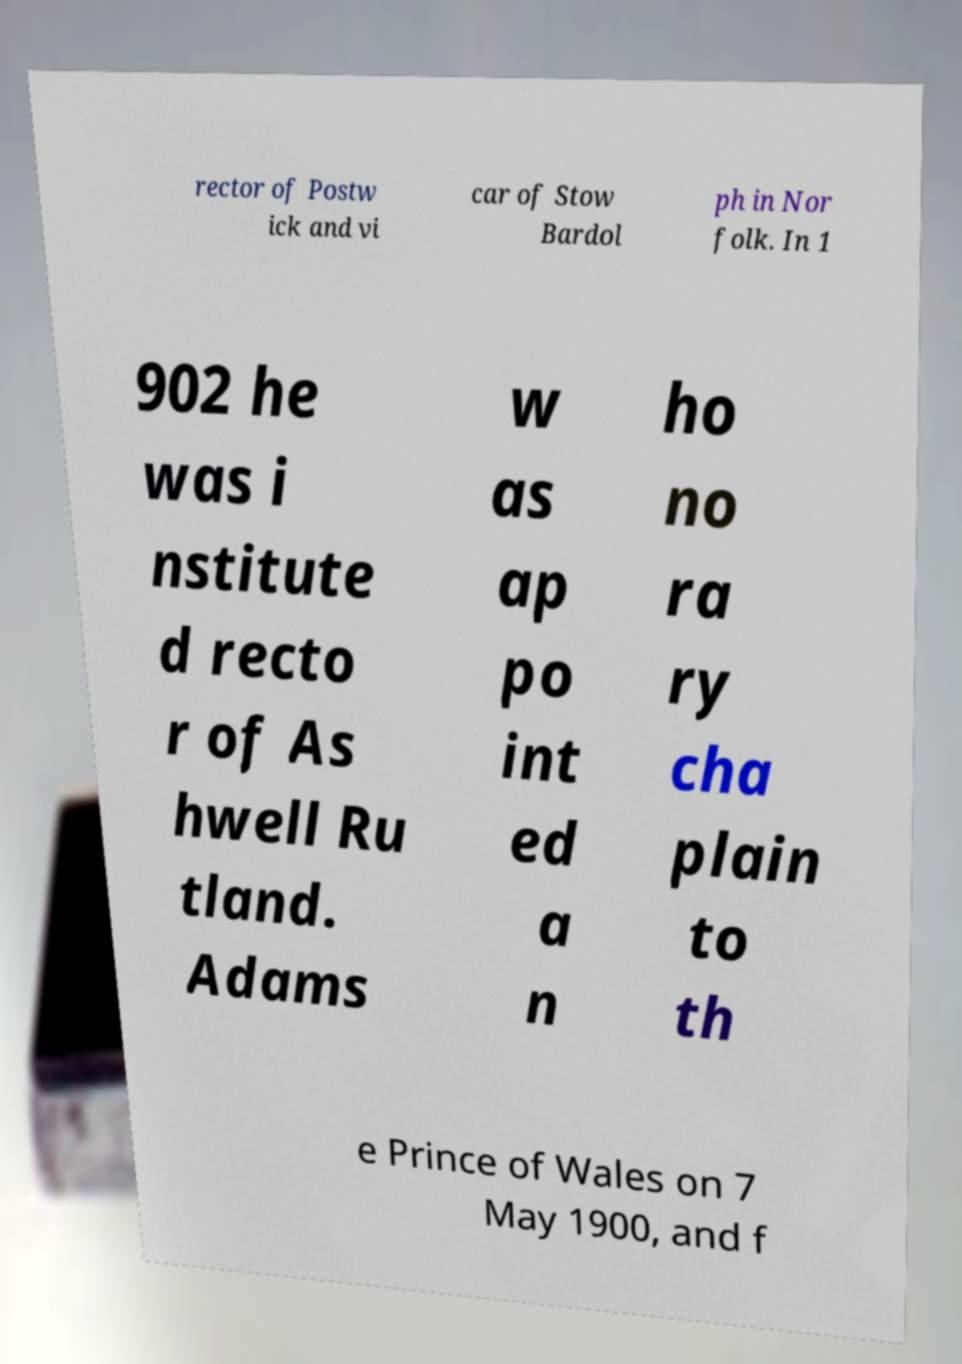Please identify and transcribe the text found in this image. rector of Postw ick and vi car of Stow Bardol ph in Nor folk. In 1 902 he was i nstitute d recto r of As hwell Ru tland. Adams w as ap po int ed a n ho no ra ry cha plain to th e Prince of Wales on 7 May 1900, and f 